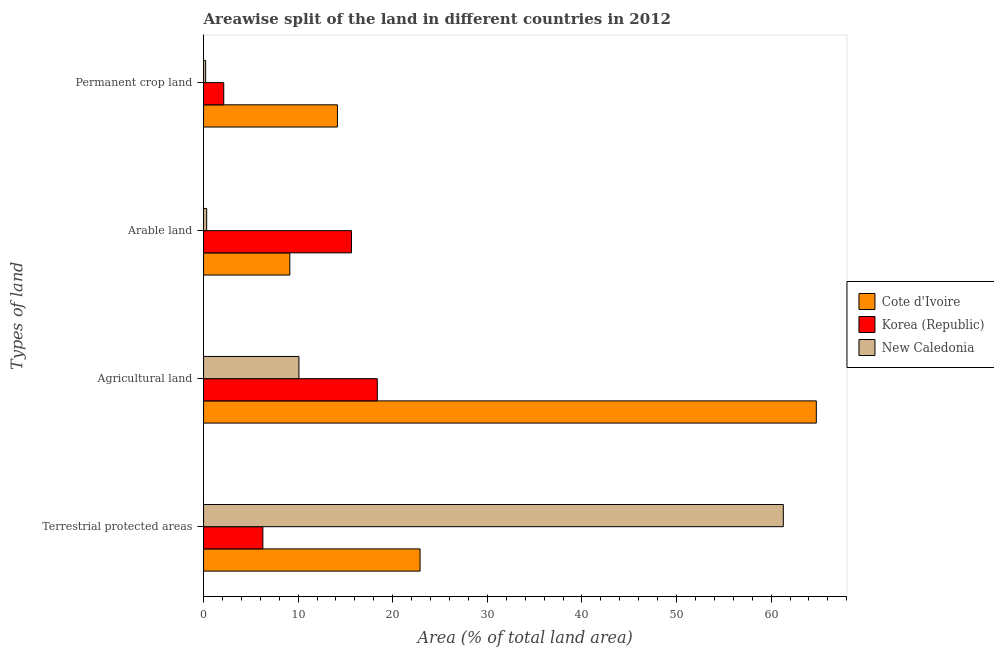How many groups of bars are there?
Offer a very short reply. 4. Are the number of bars per tick equal to the number of legend labels?
Provide a succinct answer. Yes. What is the label of the 4th group of bars from the top?
Your answer should be compact. Terrestrial protected areas. What is the percentage of area under agricultural land in New Caledonia?
Your response must be concise. 10.08. Across all countries, what is the maximum percentage of area under agricultural land?
Give a very brief answer. 64.78. Across all countries, what is the minimum percentage of area under arable land?
Offer a terse response. 0.33. In which country was the percentage of area under arable land maximum?
Offer a terse response. Korea (Republic). In which country was the percentage of area under permanent crop land minimum?
Provide a short and direct response. New Caledonia. What is the total percentage of area under permanent crop land in the graph?
Your answer should be compact. 16.5. What is the difference between the percentage of land under terrestrial protection in Cote d'Ivoire and that in New Caledonia?
Keep it short and to the point. -38.4. What is the difference between the percentage of area under agricultural land in Cote d'Ivoire and the percentage of land under terrestrial protection in New Caledonia?
Give a very brief answer. 3.49. What is the average percentage of area under agricultural land per country?
Your answer should be compact. 31.08. What is the difference between the percentage of area under arable land and percentage of area under agricultural land in New Caledonia?
Keep it short and to the point. -9.75. What is the ratio of the percentage of area under permanent crop land in Korea (Republic) to that in New Caledonia?
Keep it short and to the point. 9.75. Is the difference between the percentage of area under arable land in Cote d'Ivoire and Korea (Republic) greater than the difference between the percentage of area under agricultural land in Cote d'Ivoire and Korea (Republic)?
Your answer should be compact. No. What is the difference between the highest and the second highest percentage of area under permanent crop land?
Keep it short and to the point. 12.02. What is the difference between the highest and the lowest percentage of area under agricultural land?
Ensure brevity in your answer.  54.7. Is the sum of the percentage of area under arable land in Korea (Republic) and Cote d'Ivoire greater than the maximum percentage of area under permanent crop land across all countries?
Provide a succinct answer. Yes. Is it the case that in every country, the sum of the percentage of area under agricultural land and percentage of land under terrestrial protection is greater than the sum of percentage of area under arable land and percentage of area under permanent crop land?
Provide a succinct answer. No. What does the 3rd bar from the top in Permanent crop land represents?
Provide a succinct answer. Cote d'Ivoire. Are all the bars in the graph horizontal?
Offer a very short reply. Yes. How many countries are there in the graph?
Provide a short and direct response. 3. What is the difference between two consecutive major ticks on the X-axis?
Your answer should be very brief. 10. Are the values on the major ticks of X-axis written in scientific E-notation?
Give a very brief answer. No. How many legend labels are there?
Keep it short and to the point. 3. What is the title of the graph?
Your answer should be very brief. Areawise split of the land in different countries in 2012. What is the label or title of the X-axis?
Keep it short and to the point. Area (% of total land area). What is the label or title of the Y-axis?
Offer a very short reply. Types of land. What is the Area (% of total land area) of Cote d'Ivoire in Terrestrial protected areas?
Make the answer very short. 22.89. What is the Area (% of total land area) in Korea (Republic) in Terrestrial protected areas?
Provide a succinct answer. 6.27. What is the Area (% of total land area) of New Caledonia in Terrestrial protected areas?
Ensure brevity in your answer.  61.29. What is the Area (% of total land area) of Cote d'Ivoire in Agricultural land?
Offer a terse response. 64.78. What is the Area (% of total land area) of Korea (Republic) in Agricultural land?
Your answer should be compact. 18.37. What is the Area (% of total land area) of New Caledonia in Agricultural land?
Provide a short and direct response. 10.08. What is the Area (% of total land area) of Cote d'Ivoire in Arable land?
Provide a short and direct response. 9.12. What is the Area (% of total land area) of Korea (Republic) in Arable land?
Your answer should be compact. 15.64. What is the Area (% of total land area) of New Caledonia in Arable land?
Make the answer very short. 0.33. What is the Area (% of total land area) in Cote d'Ivoire in Permanent crop land?
Provide a succinct answer. 14.15. What is the Area (% of total land area) in Korea (Republic) in Permanent crop land?
Provide a short and direct response. 2.13. What is the Area (% of total land area) in New Caledonia in Permanent crop land?
Your response must be concise. 0.22. Across all Types of land, what is the maximum Area (% of total land area) in Cote d'Ivoire?
Provide a short and direct response. 64.78. Across all Types of land, what is the maximum Area (% of total land area) of Korea (Republic)?
Offer a terse response. 18.37. Across all Types of land, what is the maximum Area (% of total land area) of New Caledonia?
Offer a very short reply. 61.29. Across all Types of land, what is the minimum Area (% of total land area) in Cote d'Ivoire?
Provide a short and direct response. 9.12. Across all Types of land, what is the minimum Area (% of total land area) of Korea (Republic)?
Keep it short and to the point. 2.13. Across all Types of land, what is the minimum Area (% of total land area) of New Caledonia?
Make the answer very short. 0.22. What is the total Area (% of total land area) in Cote d'Ivoire in the graph?
Your response must be concise. 110.94. What is the total Area (% of total land area) of Korea (Republic) in the graph?
Keep it short and to the point. 42.41. What is the total Area (% of total land area) in New Caledonia in the graph?
Give a very brief answer. 71.92. What is the difference between the Area (% of total land area) in Cote d'Ivoire in Terrestrial protected areas and that in Agricultural land?
Offer a terse response. -41.89. What is the difference between the Area (% of total land area) in Korea (Republic) in Terrestrial protected areas and that in Agricultural land?
Make the answer very short. -12.1. What is the difference between the Area (% of total land area) in New Caledonia in Terrestrial protected areas and that in Agricultural land?
Your answer should be compact. 51.21. What is the difference between the Area (% of total land area) in Cote d'Ivoire in Terrestrial protected areas and that in Arable land?
Provide a short and direct response. 13.77. What is the difference between the Area (% of total land area) of Korea (Republic) in Terrestrial protected areas and that in Arable land?
Provide a short and direct response. -9.37. What is the difference between the Area (% of total land area) of New Caledonia in Terrestrial protected areas and that in Arable land?
Ensure brevity in your answer.  60.96. What is the difference between the Area (% of total land area) of Cote d'Ivoire in Terrestrial protected areas and that in Permanent crop land?
Offer a very short reply. 8.74. What is the difference between the Area (% of total land area) in Korea (Republic) in Terrestrial protected areas and that in Permanent crop land?
Provide a succinct answer. 4.13. What is the difference between the Area (% of total land area) in New Caledonia in Terrestrial protected areas and that in Permanent crop land?
Your answer should be very brief. 61.07. What is the difference between the Area (% of total land area) of Cote d'Ivoire in Agricultural land and that in Arable land?
Offer a very short reply. 55.66. What is the difference between the Area (% of total land area) of Korea (Republic) in Agricultural land and that in Arable land?
Give a very brief answer. 2.73. What is the difference between the Area (% of total land area) in New Caledonia in Agricultural land and that in Arable land?
Your answer should be very brief. 9.75. What is the difference between the Area (% of total land area) of Cote d'Ivoire in Agricultural land and that in Permanent crop land?
Your answer should be very brief. 50.63. What is the difference between the Area (% of total land area) of Korea (Republic) in Agricultural land and that in Permanent crop land?
Ensure brevity in your answer.  16.23. What is the difference between the Area (% of total land area) in New Caledonia in Agricultural land and that in Permanent crop land?
Provide a succinct answer. 9.86. What is the difference between the Area (% of total land area) in Cote d'Ivoire in Arable land and that in Permanent crop land?
Your answer should be very brief. -5.03. What is the difference between the Area (% of total land area) in Korea (Republic) in Arable land and that in Permanent crop land?
Make the answer very short. 13.5. What is the difference between the Area (% of total land area) of New Caledonia in Arable land and that in Permanent crop land?
Offer a terse response. 0.11. What is the difference between the Area (% of total land area) of Cote d'Ivoire in Terrestrial protected areas and the Area (% of total land area) of Korea (Republic) in Agricultural land?
Offer a terse response. 4.52. What is the difference between the Area (% of total land area) in Cote d'Ivoire in Terrestrial protected areas and the Area (% of total land area) in New Caledonia in Agricultural land?
Provide a short and direct response. 12.81. What is the difference between the Area (% of total land area) in Korea (Republic) in Terrestrial protected areas and the Area (% of total land area) in New Caledonia in Agricultural land?
Offer a very short reply. -3.81. What is the difference between the Area (% of total land area) in Cote d'Ivoire in Terrestrial protected areas and the Area (% of total land area) in Korea (Republic) in Arable land?
Offer a terse response. 7.25. What is the difference between the Area (% of total land area) in Cote d'Ivoire in Terrestrial protected areas and the Area (% of total land area) in New Caledonia in Arable land?
Make the answer very short. 22.56. What is the difference between the Area (% of total land area) in Korea (Republic) in Terrestrial protected areas and the Area (% of total land area) in New Caledonia in Arable land?
Offer a very short reply. 5.94. What is the difference between the Area (% of total land area) of Cote d'Ivoire in Terrestrial protected areas and the Area (% of total land area) of Korea (Republic) in Permanent crop land?
Your answer should be very brief. 20.75. What is the difference between the Area (% of total land area) in Cote d'Ivoire in Terrestrial protected areas and the Area (% of total land area) in New Caledonia in Permanent crop land?
Keep it short and to the point. 22.67. What is the difference between the Area (% of total land area) in Korea (Republic) in Terrestrial protected areas and the Area (% of total land area) in New Caledonia in Permanent crop land?
Offer a terse response. 6.05. What is the difference between the Area (% of total land area) in Cote d'Ivoire in Agricultural land and the Area (% of total land area) in Korea (Republic) in Arable land?
Offer a terse response. 49.14. What is the difference between the Area (% of total land area) in Cote d'Ivoire in Agricultural land and the Area (% of total land area) in New Caledonia in Arable land?
Provide a succinct answer. 64.45. What is the difference between the Area (% of total land area) in Korea (Republic) in Agricultural land and the Area (% of total land area) in New Caledonia in Arable land?
Your answer should be compact. 18.04. What is the difference between the Area (% of total land area) of Cote d'Ivoire in Agricultural land and the Area (% of total land area) of Korea (Republic) in Permanent crop land?
Keep it short and to the point. 62.65. What is the difference between the Area (% of total land area) of Cote d'Ivoire in Agricultural land and the Area (% of total land area) of New Caledonia in Permanent crop land?
Your answer should be very brief. 64.56. What is the difference between the Area (% of total land area) in Korea (Republic) in Agricultural land and the Area (% of total land area) in New Caledonia in Permanent crop land?
Offer a very short reply. 18.15. What is the difference between the Area (% of total land area) in Cote d'Ivoire in Arable land and the Area (% of total land area) in Korea (Republic) in Permanent crop land?
Keep it short and to the point. 6.98. What is the difference between the Area (% of total land area) in Cote d'Ivoire in Arable land and the Area (% of total land area) in New Caledonia in Permanent crop land?
Provide a short and direct response. 8.9. What is the difference between the Area (% of total land area) of Korea (Republic) in Arable land and the Area (% of total land area) of New Caledonia in Permanent crop land?
Offer a terse response. 15.42. What is the average Area (% of total land area) of Cote d'Ivoire per Types of land?
Your response must be concise. 27.73. What is the average Area (% of total land area) in Korea (Republic) per Types of land?
Make the answer very short. 10.6. What is the average Area (% of total land area) of New Caledonia per Types of land?
Provide a succinct answer. 17.98. What is the difference between the Area (% of total land area) in Cote d'Ivoire and Area (% of total land area) in Korea (Republic) in Terrestrial protected areas?
Provide a short and direct response. 16.62. What is the difference between the Area (% of total land area) in Cote d'Ivoire and Area (% of total land area) in New Caledonia in Terrestrial protected areas?
Give a very brief answer. -38.4. What is the difference between the Area (% of total land area) of Korea (Republic) and Area (% of total land area) of New Caledonia in Terrestrial protected areas?
Make the answer very short. -55.02. What is the difference between the Area (% of total land area) in Cote d'Ivoire and Area (% of total land area) in Korea (Republic) in Agricultural land?
Give a very brief answer. 46.41. What is the difference between the Area (% of total land area) of Cote d'Ivoire and Area (% of total land area) of New Caledonia in Agricultural land?
Ensure brevity in your answer.  54.7. What is the difference between the Area (% of total land area) of Korea (Republic) and Area (% of total land area) of New Caledonia in Agricultural land?
Keep it short and to the point. 8.28. What is the difference between the Area (% of total land area) of Cote d'Ivoire and Area (% of total land area) of Korea (Republic) in Arable land?
Make the answer very short. -6.52. What is the difference between the Area (% of total land area) of Cote d'Ivoire and Area (% of total land area) of New Caledonia in Arable land?
Your answer should be compact. 8.79. What is the difference between the Area (% of total land area) of Korea (Republic) and Area (% of total land area) of New Caledonia in Arable land?
Provide a short and direct response. 15.31. What is the difference between the Area (% of total land area) in Cote d'Ivoire and Area (% of total land area) in Korea (Republic) in Permanent crop land?
Your answer should be very brief. 12.02. What is the difference between the Area (% of total land area) of Cote d'Ivoire and Area (% of total land area) of New Caledonia in Permanent crop land?
Provide a short and direct response. 13.93. What is the difference between the Area (% of total land area) of Korea (Republic) and Area (% of total land area) of New Caledonia in Permanent crop land?
Offer a very short reply. 1.92. What is the ratio of the Area (% of total land area) in Cote d'Ivoire in Terrestrial protected areas to that in Agricultural land?
Provide a short and direct response. 0.35. What is the ratio of the Area (% of total land area) in Korea (Republic) in Terrestrial protected areas to that in Agricultural land?
Ensure brevity in your answer.  0.34. What is the ratio of the Area (% of total land area) in New Caledonia in Terrestrial protected areas to that in Agricultural land?
Provide a succinct answer. 6.08. What is the ratio of the Area (% of total land area) of Cote d'Ivoire in Terrestrial protected areas to that in Arable land?
Your response must be concise. 2.51. What is the ratio of the Area (% of total land area) in Korea (Republic) in Terrestrial protected areas to that in Arable land?
Your response must be concise. 0.4. What is the ratio of the Area (% of total land area) in New Caledonia in Terrestrial protected areas to that in Arable land?
Keep it short and to the point. 186.74. What is the ratio of the Area (% of total land area) of Cote d'Ivoire in Terrestrial protected areas to that in Permanent crop land?
Keep it short and to the point. 1.62. What is the ratio of the Area (% of total land area) in Korea (Republic) in Terrestrial protected areas to that in Permanent crop land?
Provide a short and direct response. 2.94. What is the ratio of the Area (% of total land area) of New Caledonia in Terrestrial protected areas to that in Permanent crop land?
Make the answer very short. 280.1. What is the ratio of the Area (% of total land area) of Cote d'Ivoire in Agricultural land to that in Arable land?
Your answer should be compact. 7.1. What is the ratio of the Area (% of total land area) in Korea (Republic) in Agricultural land to that in Arable land?
Offer a terse response. 1.17. What is the ratio of the Area (% of total land area) in New Caledonia in Agricultural land to that in Arable land?
Offer a terse response. 30.72. What is the ratio of the Area (% of total land area) of Cote d'Ivoire in Agricultural land to that in Permanent crop land?
Make the answer very short. 4.58. What is the ratio of the Area (% of total land area) in Korea (Republic) in Agricultural land to that in Permanent crop land?
Your answer should be compact. 8.6. What is the ratio of the Area (% of total land area) of New Caledonia in Agricultural land to that in Permanent crop land?
Provide a succinct answer. 46.08. What is the ratio of the Area (% of total land area) in Cote d'Ivoire in Arable land to that in Permanent crop land?
Your response must be concise. 0.64. What is the ratio of the Area (% of total land area) of Korea (Republic) in Arable land to that in Permanent crop land?
Provide a succinct answer. 7.33. What is the difference between the highest and the second highest Area (% of total land area) in Cote d'Ivoire?
Keep it short and to the point. 41.89. What is the difference between the highest and the second highest Area (% of total land area) in Korea (Republic)?
Provide a succinct answer. 2.73. What is the difference between the highest and the second highest Area (% of total land area) of New Caledonia?
Offer a terse response. 51.21. What is the difference between the highest and the lowest Area (% of total land area) in Cote d'Ivoire?
Offer a very short reply. 55.66. What is the difference between the highest and the lowest Area (% of total land area) of Korea (Republic)?
Keep it short and to the point. 16.23. What is the difference between the highest and the lowest Area (% of total land area) of New Caledonia?
Your answer should be compact. 61.07. 